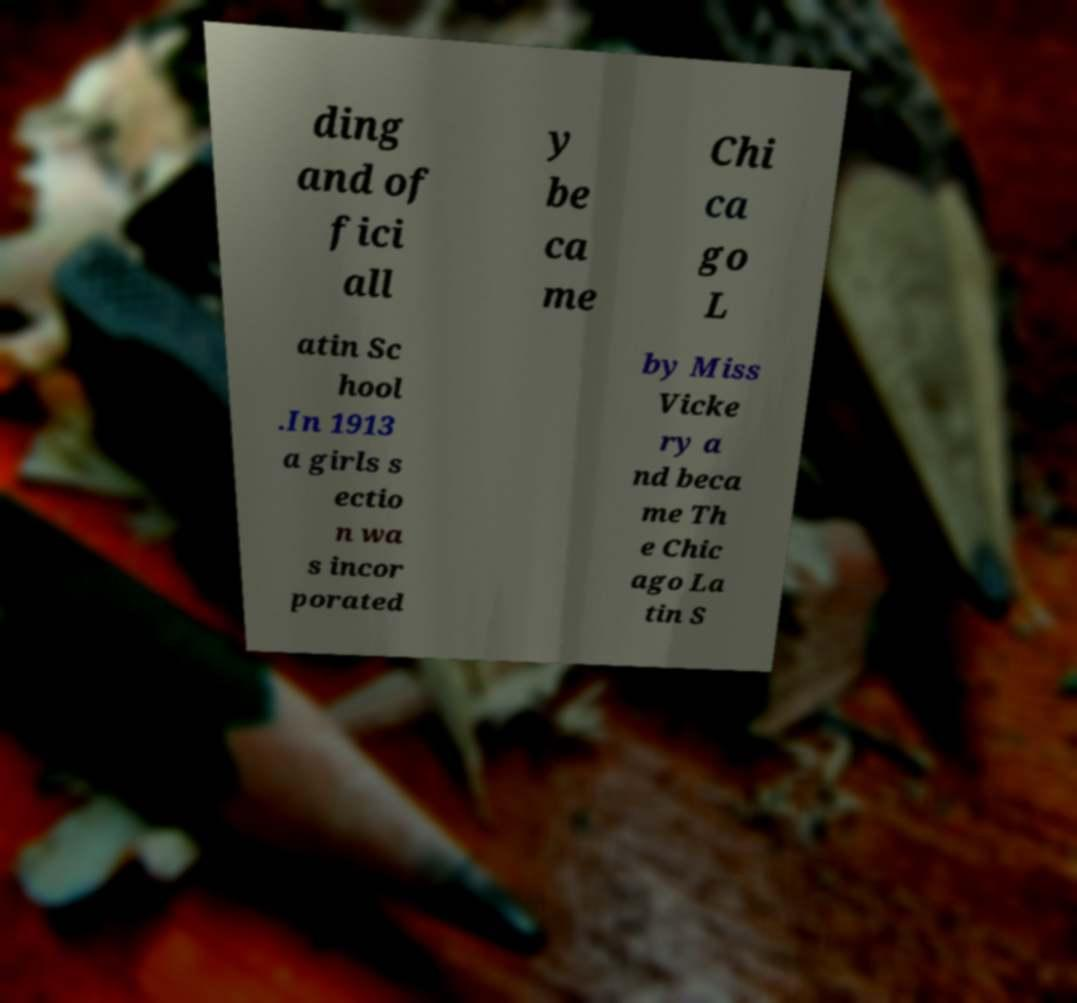Can you read and provide the text displayed in the image?This photo seems to have some interesting text. Can you extract and type it out for me? ding and of fici all y be ca me Chi ca go L atin Sc hool .In 1913 a girls s ectio n wa s incor porated by Miss Vicke ry a nd beca me Th e Chic ago La tin S 